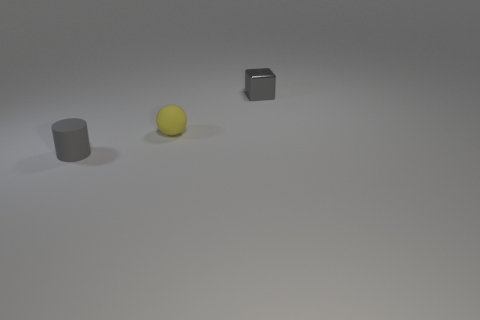Is there anything else that has the same shape as the yellow matte thing?
Provide a short and direct response. No. Is the number of tiny yellow matte balls greater than the number of matte objects?
Provide a succinct answer. No. Are there any other things of the same shape as the small gray metal object?
Offer a terse response. No. What is the shape of the tiny gray object that is behind the small gray cylinder?
Provide a succinct answer. Cube. There is a tiny gray object right of the matte thing that is in front of the sphere; how many cylinders are behind it?
Offer a terse response. 0. There is a thing that is behind the yellow matte ball; does it have the same color as the matte ball?
Provide a succinct answer. No. How many other objects are the same shape as the metallic object?
Provide a short and direct response. 0. What number of other things are made of the same material as the gray cube?
Offer a terse response. 0. The gray object that is in front of the tiny gray object behind the tiny gray thing that is left of the small shiny object is made of what material?
Your answer should be very brief. Rubber. Is the material of the tiny block the same as the small yellow sphere?
Provide a short and direct response. No. 